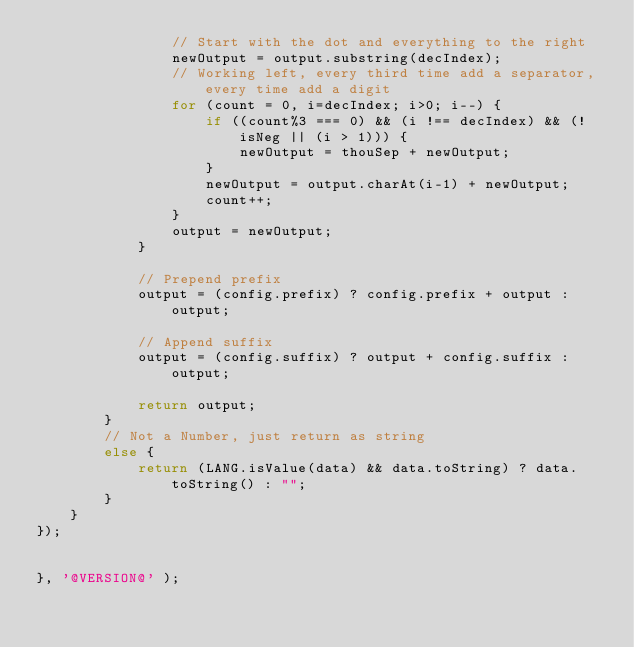Convert code to text. <code><loc_0><loc_0><loc_500><loc_500><_JavaScript_>                // Start with the dot and everything to the right
                newOutput = output.substring(decIndex);
                // Working left, every third time add a separator, every time add a digit
                for (count = 0, i=decIndex; i>0; i--) {
                    if ((count%3 === 0) && (i !== decIndex) && (!isNeg || (i > 1))) {
                        newOutput = thouSep + newOutput;
                    }
                    newOutput = output.charAt(i-1) + newOutput;
                    count++;
                }
                output = newOutput;
            }

            // Prepend prefix
            output = (config.prefix) ? config.prefix + output : output;

            // Append suffix
            output = (config.suffix) ? output + config.suffix : output;

            return output;
        }
        // Not a Number, just return as string
        else {
            return (LANG.isValue(data) && data.toString) ? data.toString() : "";
        }
    }
});


}, '@VERSION@' );
</code> 